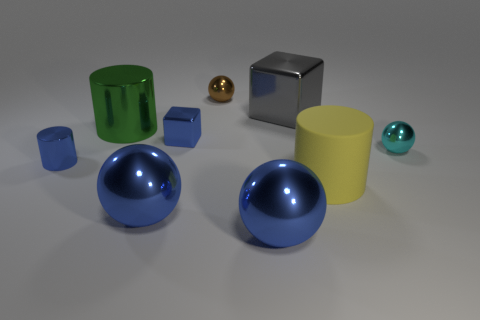How many blue balls must be subtracted to get 1 blue balls? 1 Subtract all small shiny cylinders. How many cylinders are left? 2 Subtract all brown cylinders. How many blue spheres are left? 2 Subtract all brown balls. How many balls are left? 3 Subtract all cubes. How many objects are left? 7 Subtract all tiny cyan objects. Subtract all brown metallic objects. How many objects are left? 7 Add 1 large gray shiny blocks. How many large gray shiny blocks are left? 2 Add 4 yellow matte objects. How many yellow matte objects exist? 5 Subtract 0 gray cylinders. How many objects are left? 9 Subtract all purple cylinders. Subtract all cyan blocks. How many cylinders are left? 3 